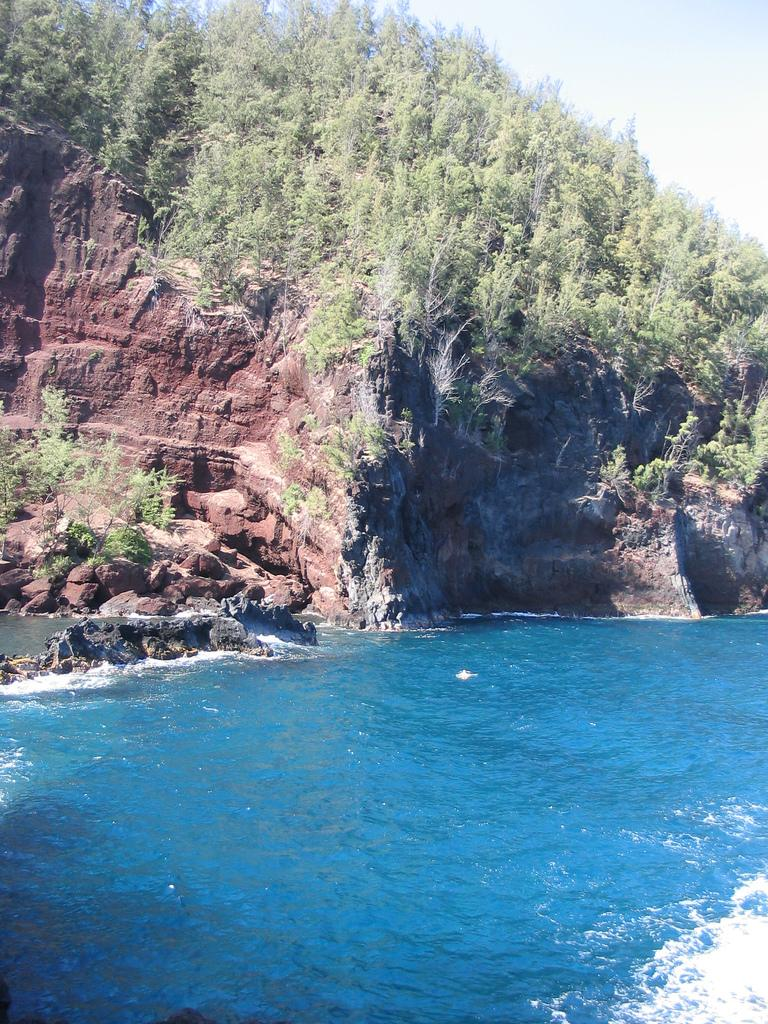What type of vegetation can be seen in the image? There are many plants in the image. What geographical feature is present in the image? There is a hill in the image. What part of the natural environment is visible in the image? The sky is visible in the image. What body of water can be seen in the image? There is a lake in the image. What type of rice is being harvested in the image? There is no rice being harvested in the image; it features plants, a hill, the sky, and a lake. What religious symbols can be seen in the image? There are no religious symbols present in the image. 